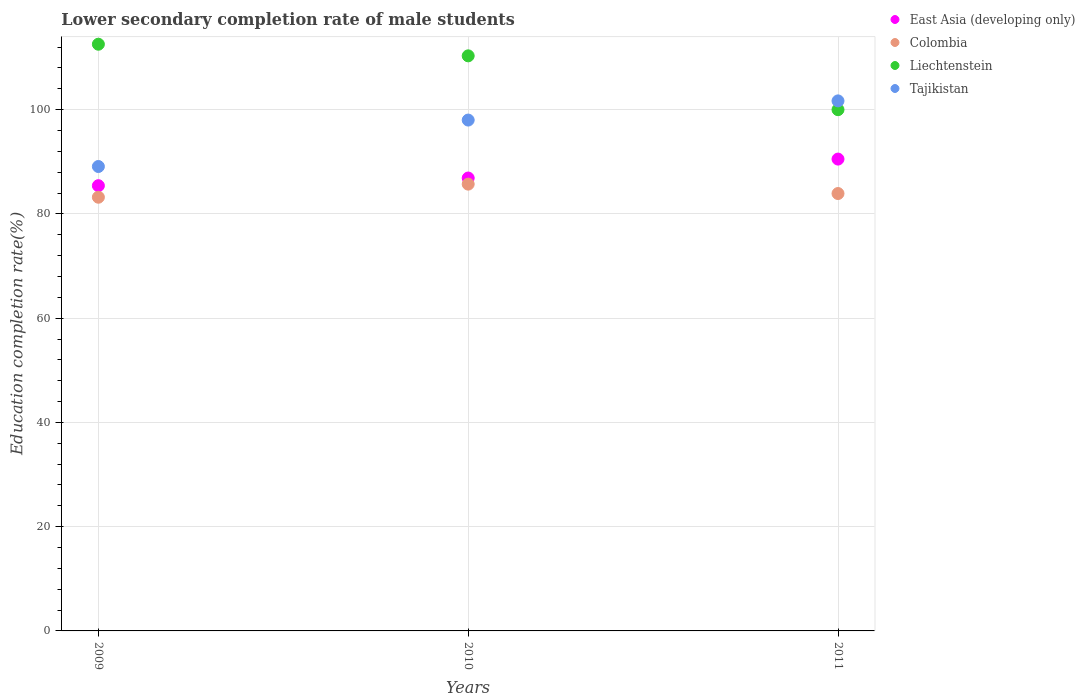Is the number of dotlines equal to the number of legend labels?
Provide a succinct answer. Yes. What is the lower secondary completion rate of male students in East Asia (developing only) in 2009?
Offer a terse response. 85.42. Across all years, what is the maximum lower secondary completion rate of male students in Liechtenstein?
Provide a short and direct response. 112.56. Across all years, what is the minimum lower secondary completion rate of male students in East Asia (developing only)?
Provide a short and direct response. 85.42. What is the total lower secondary completion rate of male students in Tajikistan in the graph?
Give a very brief answer. 288.79. What is the difference between the lower secondary completion rate of male students in Liechtenstein in 2010 and that in 2011?
Your response must be concise. 10.33. What is the difference between the lower secondary completion rate of male students in Colombia in 2011 and the lower secondary completion rate of male students in Tajikistan in 2010?
Give a very brief answer. -14.09. What is the average lower secondary completion rate of male students in Tajikistan per year?
Make the answer very short. 96.26. In the year 2011, what is the difference between the lower secondary completion rate of male students in Tajikistan and lower secondary completion rate of male students in Liechtenstein?
Provide a short and direct response. 1.69. In how many years, is the lower secondary completion rate of male students in Liechtenstein greater than 92 %?
Ensure brevity in your answer.  3. What is the ratio of the lower secondary completion rate of male students in Tajikistan in 2009 to that in 2010?
Offer a very short reply. 0.91. Is the lower secondary completion rate of male students in Colombia in 2010 less than that in 2011?
Your answer should be very brief. No. Is the difference between the lower secondary completion rate of male students in Tajikistan in 2010 and 2011 greater than the difference between the lower secondary completion rate of male students in Liechtenstein in 2010 and 2011?
Make the answer very short. No. What is the difference between the highest and the second highest lower secondary completion rate of male students in East Asia (developing only)?
Ensure brevity in your answer.  3.63. What is the difference between the highest and the lowest lower secondary completion rate of male students in Tajikistan?
Provide a short and direct response. 12.59. Is it the case that in every year, the sum of the lower secondary completion rate of male students in Colombia and lower secondary completion rate of male students in Liechtenstein  is greater than the sum of lower secondary completion rate of male students in Tajikistan and lower secondary completion rate of male students in East Asia (developing only)?
Make the answer very short. No. Is it the case that in every year, the sum of the lower secondary completion rate of male students in Colombia and lower secondary completion rate of male students in East Asia (developing only)  is greater than the lower secondary completion rate of male students in Liechtenstein?
Ensure brevity in your answer.  Yes. Is the lower secondary completion rate of male students in East Asia (developing only) strictly less than the lower secondary completion rate of male students in Liechtenstein over the years?
Provide a short and direct response. Yes. How many dotlines are there?
Make the answer very short. 4. How many years are there in the graph?
Offer a very short reply. 3. What is the difference between two consecutive major ticks on the Y-axis?
Your answer should be very brief. 20. Are the values on the major ticks of Y-axis written in scientific E-notation?
Your answer should be compact. No. Does the graph contain any zero values?
Offer a very short reply. No. Does the graph contain grids?
Your response must be concise. Yes. Where does the legend appear in the graph?
Your answer should be compact. Top right. How are the legend labels stacked?
Keep it short and to the point. Vertical. What is the title of the graph?
Your answer should be compact. Lower secondary completion rate of male students. Does "Australia" appear as one of the legend labels in the graph?
Give a very brief answer. No. What is the label or title of the Y-axis?
Your response must be concise. Education completion rate(%). What is the Education completion rate(%) in East Asia (developing only) in 2009?
Offer a terse response. 85.42. What is the Education completion rate(%) of Colombia in 2009?
Offer a terse response. 83.21. What is the Education completion rate(%) in Liechtenstein in 2009?
Ensure brevity in your answer.  112.56. What is the Education completion rate(%) in Tajikistan in 2009?
Keep it short and to the point. 89.1. What is the Education completion rate(%) in East Asia (developing only) in 2010?
Give a very brief answer. 86.89. What is the Education completion rate(%) in Colombia in 2010?
Ensure brevity in your answer.  85.72. What is the Education completion rate(%) of Liechtenstein in 2010?
Make the answer very short. 110.33. What is the Education completion rate(%) of Tajikistan in 2010?
Your answer should be very brief. 98.01. What is the Education completion rate(%) in East Asia (developing only) in 2011?
Provide a short and direct response. 90.52. What is the Education completion rate(%) in Colombia in 2011?
Give a very brief answer. 83.91. What is the Education completion rate(%) in Liechtenstein in 2011?
Ensure brevity in your answer.  100. What is the Education completion rate(%) of Tajikistan in 2011?
Your answer should be compact. 101.69. Across all years, what is the maximum Education completion rate(%) in East Asia (developing only)?
Your answer should be very brief. 90.52. Across all years, what is the maximum Education completion rate(%) of Colombia?
Your response must be concise. 85.72. Across all years, what is the maximum Education completion rate(%) in Liechtenstein?
Offer a terse response. 112.56. Across all years, what is the maximum Education completion rate(%) in Tajikistan?
Your answer should be compact. 101.69. Across all years, what is the minimum Education completion rate(%) in East Asia (developing only)?
Ensure brevity in your answer.  85.42. Across all years, what is the minimum Education completion rate(%) of Colombia?
Give a very brief answer. 83.21. Across all years, what is the minimum Education completion rate(%) in Tajikistan?
Provide a short and direct response. 89.1. What is the total Education completion rate(%) in East Asia (developing only) in the graph?
Offer a very short reply. 262.83. What is the total Education completion rate(%) of Colombia in the graph?
Offer a very short reply. 252.84. What is the total Education completion rate(%) in Liechtenstein in the graph?
Give a very brief answer. 322.89. What is the total Education completion rate(%) of Tajikistan in the graph?
Ensure brevity in your answer.  288.79. What is the difference between the Education completion rate(%) in East Asia (developing only) in 2009 and that in 2010?
Ensure brevity in your answer.  -1.47. What is the difference between the Education completion rate(%) in Colombia in 2009 and that in 2010?
Offer a terse response. -2.51. What is the difference between the Education completion rate(%) in Liechtenstein in 2009 and that in 2010?
Offer a terse response. 2.23. What is the difference between the Education completion rate(%) of Tajikistan in 2009 and that in 2010?
Ensure brevity in your answer.  -8.91. What is the difference between the Education completion rate(%) of East Asia (developing only) in 2009 and that in 2011?
Give a very brief answer. -5.11. What is the difference between the Education completion rate(%) in Colombia in 2009 and that in 2011?
Keep it short and to the point. -0.71. What is the difference between the Education completion rate(%) of Liechtenstein in 2009 and that in 2011?
Make the answer very short. 12.56. What is the difference between the Education completion rate(%) in Tajikistan in 2009 and that in 2011?
Make the answer very short. -12.59. What is the difference between the Education completion rate(%) in East Asia (developing only) in 2010 and that in 2011?
Make the answer very short. -3.63. What is the difference between the Education completion rate(%) of Colombia in 2010 and that in 2011?
Make the answer very short. 1.8. What is the difference between the Education completion rate(%) in Liechtenstein in 2010 and that in 2011?
Provide a succinct answer. 10.33. What is the difference between the Education completion rate(%) of Tajikistan in 2010 and that in 2011?
Your answer should be compact. -3.68. What is the difference between the Education completion rate(%) of East Asia (developing only) in 2009 and the Education completion rate(%) of Colombia in 2010?
Keep it short and to the point. -0.3. What is the difference between the Education completion rate(%) in East Asia (developing only) in 2009 and the Education completion rate(%) in Liechtenstein in 2010?
Ensure brevity in your answer.  -24.91. What is the difference between the Education completion rate(%) of East Asia (developing only) in 2009 and the Education completion rate(%) of Tajikistan in 2010?
Provide a short and direct response. -12.59. What is the difference between the Education completion rate(%) in Colombia in 2009 and the Education completion rate(%) in Liechtenstein in 2010?
Your answer should be very brief. -27.12. What is the difference between the Education completion rate(%) of Colombia in 2009 and the Education completion rate(%) of Tajikistan in 2010?
Provide a succinct answer. -14.8. What is the difference between the Education completion rate(%) in Liechtenstein in 2009 and the Education completion rate(%) in Tajikistan in 2010?
Your response must be concise. 14.55. What is the difference between the Education completion rate(%) in East Asia (developing only) in 2009 and the Education completion rate(%) in Colombia in 2011?
Give a very brief answer. 1.5. What is the difference between the Education completion rate(%) of East Asia (developing only) in 2009 and the Education completion rate(%) of Liechtenstein in 2011?
Your response must be concise. -14.58. What is the difference between the Education completion rate(%) of East Asia (developing only) in 2009 and the Education completion rate(%) of Tajikistan in 2011?
Provide a short and direct response. -16.27. What is the difference between the Education completion rate(%) in Colombia in 2009 and the Education completion rate(%) in Liechtenstein in 2011?
Give a very brief answer. -16.8. What is the difference between the Education completion rate(%) in Colombia in 2009 and the Education completion rate(%) in Tajikistan in 2011?
Your answer should be compact. -18.48. What is the difference between the Education completion rate(%) of Liechtenstein in 2009 and the Education completion rate(%) of Tajikistan in 2011?
Ensure brevity in your answer.  10.87. What is the difference between the Education completion rate(%) in East Asia (developing only) in 2010 and the Education completion rate(%) in Colombia in 2011?
Provide a short and direct response. 2.97. What is the difference between the Education completion rate(%) of East Asia (developing only) in 2010 and the Education completion rate(%) of Liechtenstein in 2011?
Ensure brevity in your answer.  -13.11. What is the difference between the Education completion rate(%) in East Asia (developing only) in 2010 and the Education completion rate(%) in Tajikistan in 2011?
Make the answer very short. -14.8. What is the difference between the Education completion rate(%) of Colombia in 2010 and the Education completion rate(%) of Liechtenstein in 2011?
Offer a very short reply. -14.28. What is the difference between the Education completion rate(%) in Colombia in 2010 and the Education completion rate(%) in Tajikistan in 2011?
Your answer should be very brief. -15.97. What is the difference between the Education completion rate(%) in Liechtenstein in 2010 and the Education completion rate(%) in Tajikistan in 2011?
Offer a terse response. 8.64. What is the average Education completion rate(%) of East Asia (developing only) per year?
Keep it short and to the point. 87.61. What is the average Education completion rate(%) of Colombia per year?
Offer a very short reply. 84.28. What is the average Education completion rate(%) in Liechtenstein per year?
Offer a terse response. 107.63. What is the average Education completion rate(%) in Tajikistan per year?
Ensure brevity in your answer.  96.26. In the year 2009, what is the difference between the Education completion rate(%) of East Asia (developing only) and Education completion rate(%) of Colombia?
Provide a short and direct response. 2.21. In the year 2009, what is the difference between the Education completion rate(%) in East Asia (developing only) and Education completion rate(%) in Liechtenstein?
Offer a terse response. -27.14. In the year 2009, what is the difference between the Education completion rate(%) of East Asia (developing only) and Education completion rate(%) of Tajikistan?
Provide a succinct answer. -3.68. In the year 2009, what is the difference between the Education completion rate(%) in Colombia and Education completion rate(%) in Liechtenstein?
Your answer should be very brief. -29.35. In the year 2009, what is the difference between the Education completion rate(%) in Colombia and Education completion rate(%) in Tajikistan?
Ensure brevity in your answer.  -5.89. In the year 2009, what is the difference between the Education completion rate(%) of Liechtenstein and Education completion rate(%) of Tajikistan?
Offer a terse response. 23.46. In the year 2010, what is the difference between the Education completion rate(%) of East Asia (developing only) and Education completion rate(%) of Colombia?
Make the answer very short. 1.17. In the year 2010, what is the difference between the Education completion rate(%) of East Asia (developing only) and Education completion rate(%) of Liechtenstein?
Your answer should be very brief. -23.44. In the year 2010, what is the difference between the Education completion rate(%) in East Asia (developing only) and Education completion rate(%) in Tajikistan?
Your answer should be compact. -11.12. In the year 2010, what is the difference between the Education completion rate(%) in Colombia and Education completion rate(%) in Liechtenstein?
Make the answer very short. -24.61. In the year 2010, what is the difference between the Education completion rate(%) in Colombia and Education completion rate(%) in Tajikistan?
Your answer should be very brief. -12.29. In the year 2010, what is the difference between the Education completion rate(%) in Liechtenstein and Education completion rate(%) in Tajikistan?
Your answer should be compact. 12.32. In the year 2011, what is the difference between the Education completion rate(%) in East Asia (developing only) and Education completion rate(%) in Colombia?
Offer a terse response. 6.61. In the year 2011, what is the difference between the Education completion rate(%) in East Asia (developing only) and Education completion rate(%) in Liechtenstein?
Give a very brief answer. -9.48. In the year 2011, what is the difference between the Education completion rate(%) in East Asia (developing only) and Education completion rate(%) in Tajikistan?
Offer a terse response. -11.16. In the year 2011, what is the difference between the Education completion rate(%) of Colombia and Education completion rate(%) of Liechtenstein?
Offer a terse response. -16.09. In the year 2011, what is the difference between the Education completion rate(%) of Colombia and Education completion rate(%) of Tajikistan?
Provide a short and direct response. -17.77. In the year 2011, what is the difference between the Education completion rate(%) of Liechtenstein and Education completion rate(%) of Tajikistan?
Offer a very short reply. -1.69. What is the ratio of the Education completion rate(%) in East Asia (developing only) in 2009 to that in 2010?
Offer a very short reply. 0.98. What is the ratio of the Education completion rate(%) of Colombia in 2009 to that in 2010?
Your answer should be compact. 0.97. What is the ratio of the Education completion rate(%) in Liechtenstein in 2009 to that in 2010?
Offer a very short reply. 1.02. What is the ratio of the Education completion rate(%) in Tajikistan in 2009 to that in 2010?
Keep it short and to the point. 0.91. What is the ratio of the Education completion rate(%) of East Asia (developing only) in 2009 to that in 2011?
Ensure brevity in your answer.  0.94. What is the ratio of the Education completion rate(%) in Liechtenstein in 2009 to that in 2011?
Keep it short and to the point. 1.13. What is the ratio of the Education completion rate(%) of Tajikistan in 2009 to that in 2011?
Ensure brevity in your answer.  0.88. What is the ratio of the Education completion rate(%) of East Asia (developing only) in 2010 to that in 2011?
Your response must be concise. 0.96. What is the ratio of the Education completion rate(%) of Colombia in 2010 to that in 2011?
Provide a short and direct response. 1.02. What is the ratio of the Education completion rate(%) in Liechtenstein in 2010 to that in 2011?
Your answer should be very brief. 1.1. What is the ratio of the Education completion rate(%) in Tajikistan in 2010 to that in 2011?
Make the answer very short. 0.96. What is the difference between the highest and the second highest Education completion rate(%) of East Asia (developing only)?
Give a very brief answer. 3.63. What is the difference between the highest and the second highest Education completion rate(%) of Colombia?
Provide a succinct answer. 1.8. What is the difference between the highest and the second highest Education completion rate(%) in Liechtenstein?
Offer a terse response. 2.23. What is the difference between the highest and the second highest Education completion rate(%) of Tajikistan?
Your response must be concise. 3.68. What is the difference between the highest and the lowest Education completion rate(%) of East Asia (developing only)?
Ensure brevity in your answer.  5.11. What is the difference between the highest and the lowest Education completion rate(%) in Colombia?
Provide a succinct answer. 2.51. What is the difference between the highest and the lowest Education completion rate(%) in Liechtenstein?
Offer a terse response. 12.56. What is the difference between the highest and the lowest Education completion rate(%) in Tajikistan?
Offer a terse response. 12.59. 